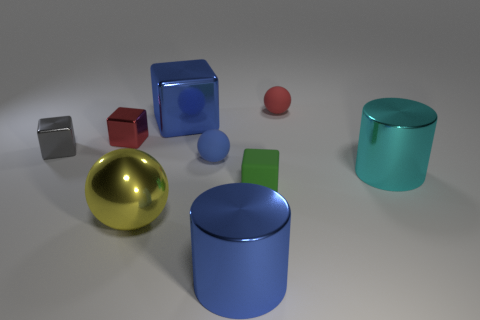How many cylinders are either small red things or green objects?
Keep it short and to the point. 0. There is a large blue metal object that is behind the tiny gray metal object; how many large blue blocks are in front of it?
Your response must be concise. 0. Is the green thing made of the same material as the small red cube?
Your answer should be compact. No. What is the size of the rubber object that is the same color as the large block?
Your answer should be very brief. Small. Are there any red blocks that have the same material as the large yellow thing?
Make the answer very short. Yes. The metallic cylinder that is to the left of the large shiny thing to the right of the rubber thing that is behind the small gray metallic cube is what color?
Keep it short and to the point. Blue. What number of blue things are small things or large cubes?
Make the answer very short. 2. How many tiny purple rubber objects are the same shape as the green rubber object?
Offer a very short reply. 0. There is a yellow metallic thing that is the same size as the cyan thing; what shape is it?
Provide a short and direct response. Sphere. Are there any large blue metallic objects to the right of the big yellow shiny thing?
Your answer should be very brief. Yes. 